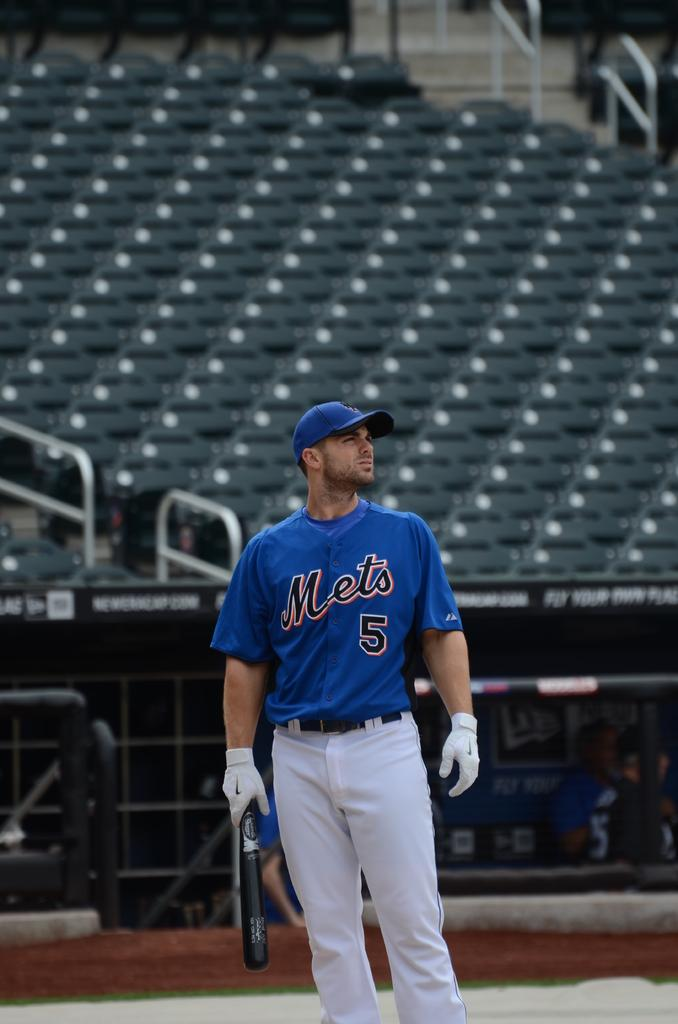Provide a one-sentence caption for the provided image. a Mets 5 player waiting to bat on the field. 